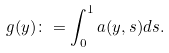Convert formula to latex. <formula><loc_0><loc_0><loc_500><loc_500>g ( y ) \colon = \int _ { 0 } ^ { 1 } a ( y , s ) d s .</formula> 